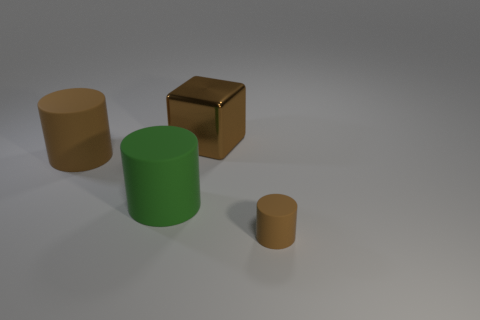Subtract all big rubber cylinders. How many cylinders are left? 1 Subtract all purple blocks. How many brown cylinders are left? 2 Add 1 big green rubber things. How many objects exist? 5 Subtract all blocks. How many objects are left? 3 Subtract all yellow cylinders. Subtract all yellow balls. How many cylinders are left? 3 Subtract all large red cylinders. Subtract all big metallic things. How many objects are left? 3 Add 2 big cylinders. How many big cylinders are left? 4 Add 4 large gray rubber objects. How many large gray rubber objects exist? 4 Subtract 0 red spheres. How many objects are left? 4 